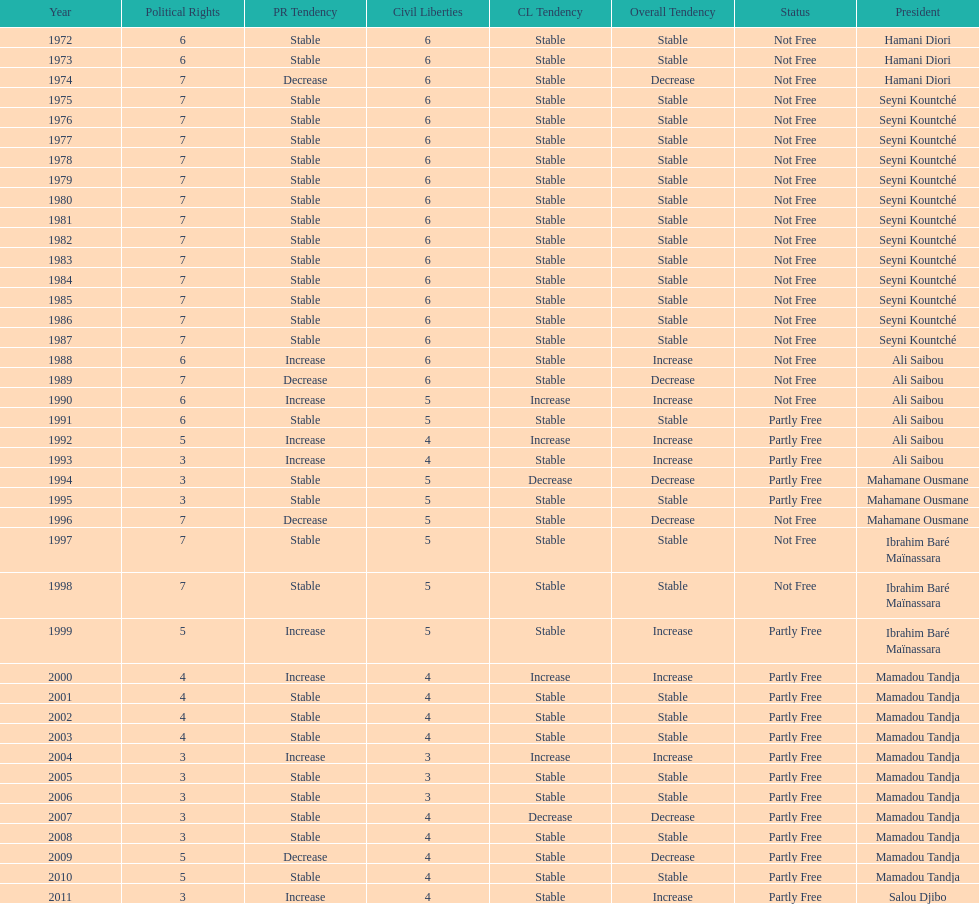How many times was the political rights listed as seven? 18. 